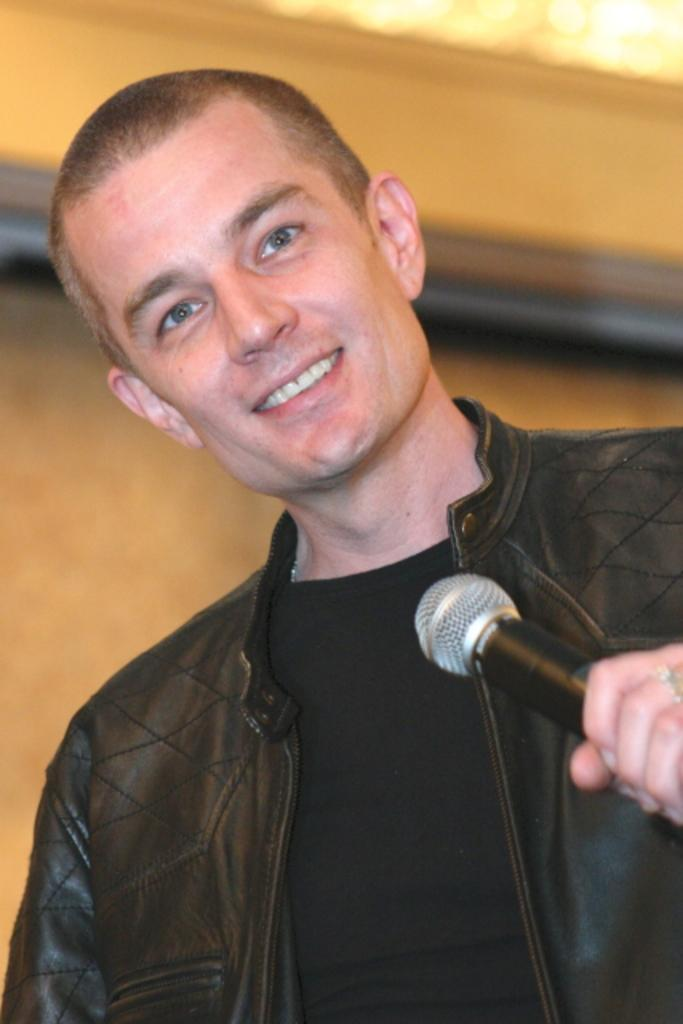What is the main subject of the image? There is a person standing in the middle of the image. What is the person holding in the image? The person is holding a microphone. What can be seen behind the person in the image? There is a wall visible behind the person. What type of scissors is the person using to cut the property in the image? There are no scissors or property visible in the image; the person is holding a microphone and standing in front of a wall. 